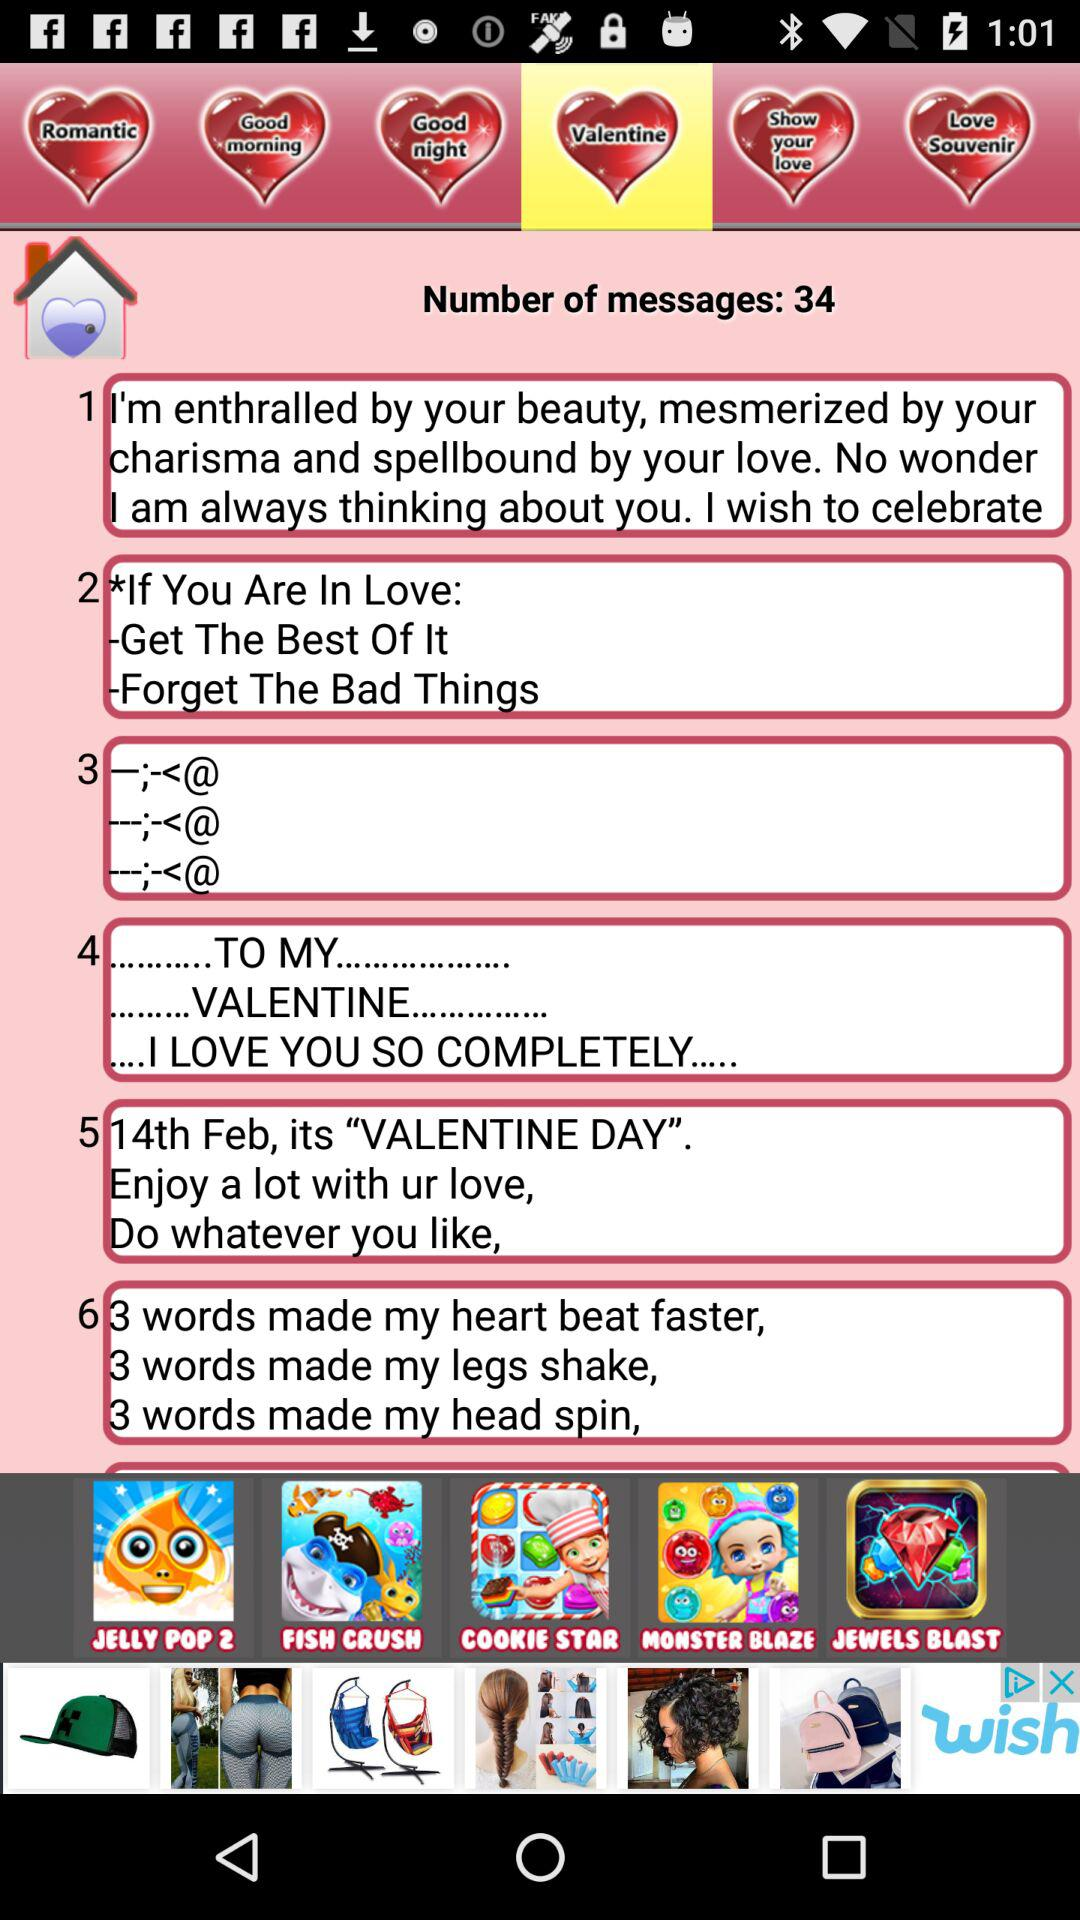What is the date for Valentine's Day? Valentine's Day is on February 14th. 